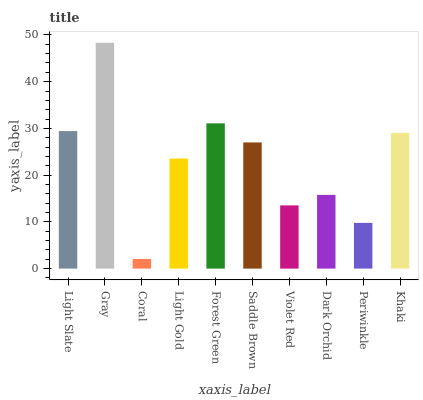Is Coral the minimum?
Answer yes or no. Yes. Is Gray the maximum?
Answer yes or no. Yes. Is Gray the minimum?
Answer yes or no. No. Is Coral the maximum?
Answer yes or no. No. Is Gray greater than Coral?
Answer yes or no. Yes. Is Coral less than Gray?
Answer yes or no. Yes. Is Coral greater than Gray?
Answer yes or no. No. Is Gray less than Coral?
Answer yes or no. No. Is Saddle Brown the high median?
Answer yes or no. Yes. Is Light Gold the low median?
Answer yes or no. Yes. Is Forest Green the high median?
Answer yes or no. No. Is Dark Orchid the low median?
Answer yes or no. No. 